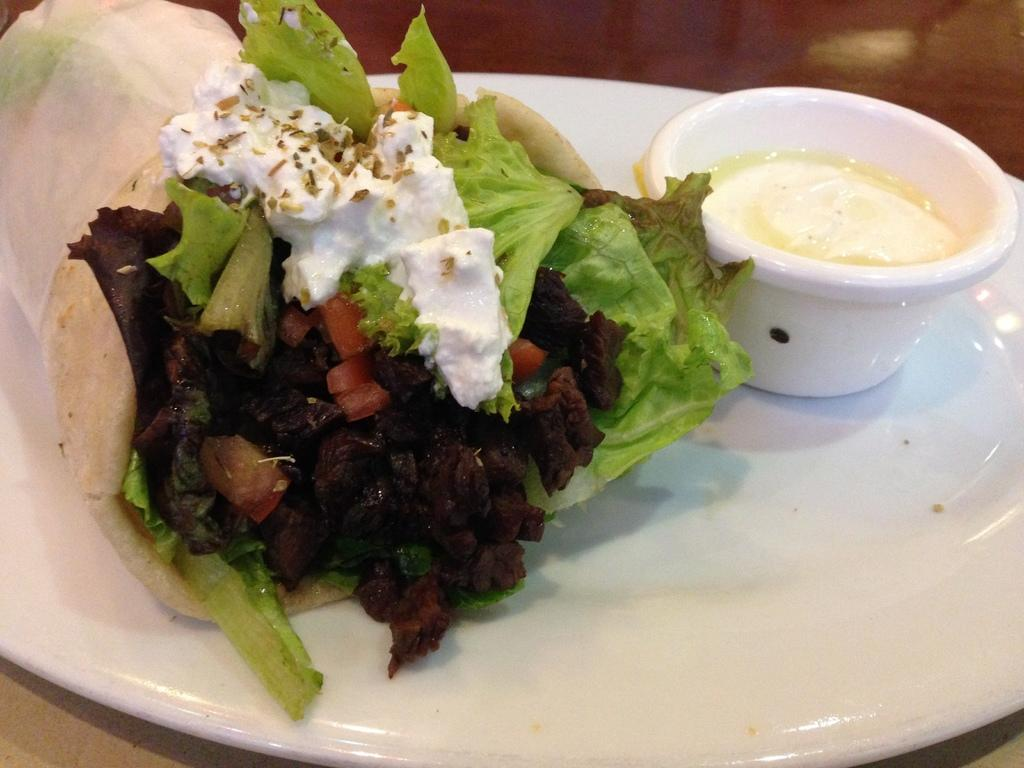What is present on the table in the image? There is a plate and a bowl in the image. What can be found inside the bowl and on the plate? There are food items in the image. Where might this image have been taken? The image may have been taken in a room, as there is a table present. Can you see a snail crawling on the patch in the image? There is no snail or patch present in the image. 